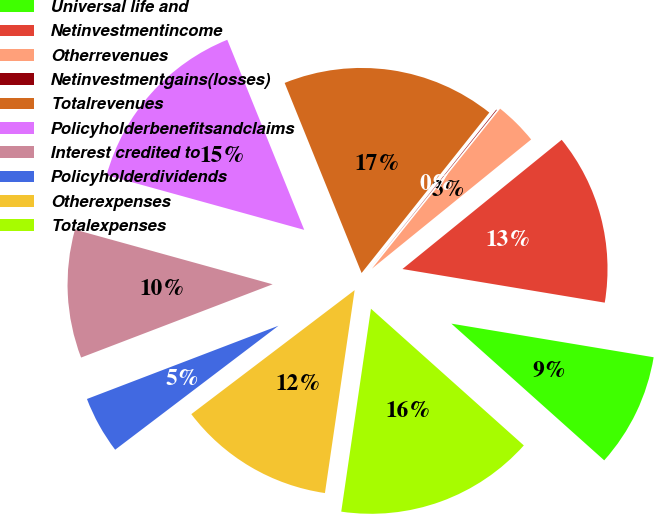Convert chart. <chart><loc_0><loc_0><loc_500><loc_500><pie_chart><fcel>Universal life and<fcel>Netinvestmentincome<fcel>Otherrevenues<fcel>Netinvestmentgains(losses)<fcel>Totalrevenues<fcel>Policyholderbenefitsandclaims<fcel>Interest credited to<fcel>Policyholderdividends<fcel>Otherexpenses<fcel>Totalexpenses<nl><fcel>8.99%<fcel>13.47%<fcel>3.4%<fcel>0.05%<fcel>16.82%<fcel>14.58%<fcel>10.11%<fcel>4.52%<fcel>12.35%<fcel>15.7%<nl></chart> 